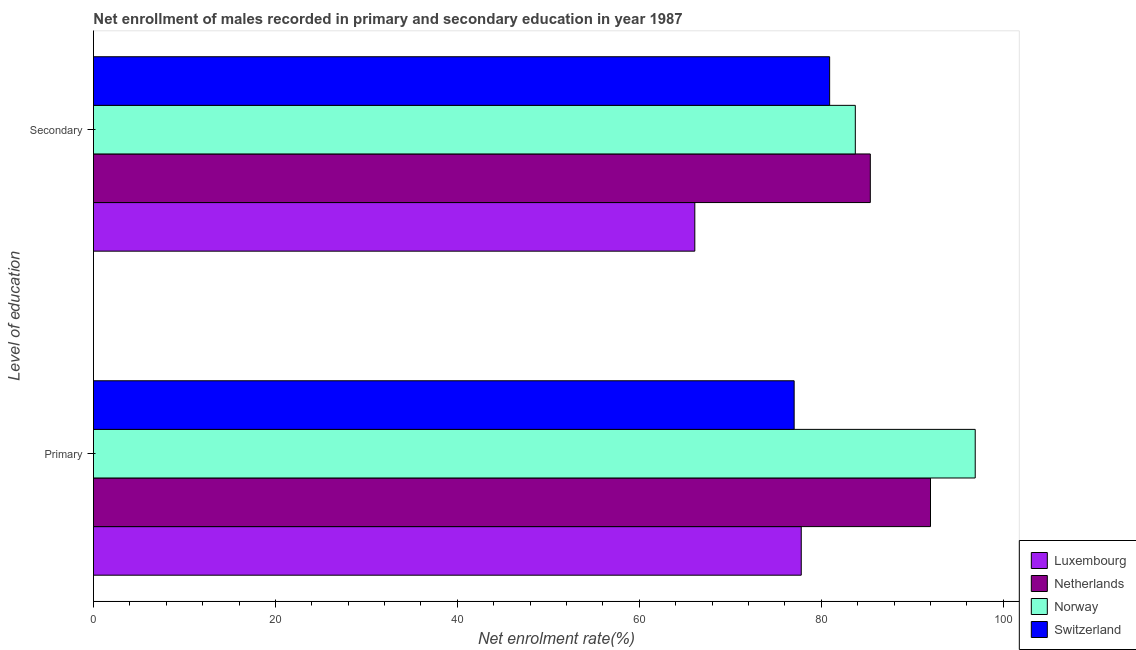How many groups of bars are there?
Your answer should be compact. 2. Are the number of bars per tick equal to the number of legend labels?
Keep it short and to the point. Yes. How many bars are there on the 2nd tick from the top?
Provide a short and direct response. 4. How many bars are there on the 1st tick from the bottom?
Provide a succinct answer. 4. What is the label of the 2nd group of bars from the top?
Give a very brief answer. Primary. What is the enrollment rate in secondary education in Luxembourg?
Make the answer very short. 66.1. Across all countries, what is the maximum enrollment rate in primary education?
Provide a succinct answer. 96.92. Across all countries, what is the minimum enrollment rate in primary education?
Your response must be concise. 77.02. In which country was the enrollment rate in secondary education maximum?
Offer a very short reply. Netherlands. In which country was the enrollment rate in primary education minimum?
Offer a very short reply. Switzerland. What is the total enrollment rate in secondary education in the graph?
Your response must be concise. 316.15. What is the difference between the enrollment rate in primary education in Luxembourg and that in Norway?
Offer a terse response. -19.12. What is the difference between the enrollment rate in secondary education in Luxembourg and the enrollment rate in primary education in Netherlands?
Your answer should be very brief. -25.91. What is the average enrollment rate in secondary education per country?
Your response must be concise. 79.04. What is the difference between the enrollment rate in primary education and enrollment rate in secondary education in Luxembourg?
Make the answer very short. 11.7. In how many countries, is the enrollment rate in secondary education greater than 32 %?
Your answer should be compact. 4. What is the ratio of the enrollment rate in primary education in Netherlands to that in Luxembourg?
Provide a succinct answer. 1.18. What does the 3rd bar from the top in Primary represents?
Provide a short and direct response. Netherlands. What does the 1st bar from the bottom in Secondary represents?
Your response must be concise. Luxembourg. Are all the bars in the graph horizontal?
Make the answer very short. Yes. How many countries are there in the graph?
Provide a short and direct response. 4. Does the graph contain any zero values?
Keep it short and to the point. No. Where does the legend appear in the graph?
Your response must be concise. Bottom right. How many legend labels are there?
Offer a terse response. 4. What is the title of the graph?
Make the answer very short. Net enrollment of males recorded in primary and secondary education in year 1987. Does "High income: OECD" appear as one of the legend labels in the graph?
Give a very brief answer. No. What is the label or title of the X-axis?
Your response must be concise. Net enrolment rate(%). What is the label or title of the Y-axis?
Keep it short and to the point. Level of education. What is the Net enrolment rate(%) of Luxembourg in Primary?
Your answer should be very brief. 77.8. What is the Net enrolment rate(%) in Netherlands in Primary?
Keep it short and to the point. 92. What is the Net enrolment rate(%) in Norway in Primary?
Ensure brevity in your answer.  96.92. What is the Net enrolment rate(%) of Switzerland in Primary?
Offer a very short reply. 77.02. What is the Net enrolment rate(%) of Luxembourg in Secondary?
Ensure brevity in your answer.  66.1. What is the Net enrolment rate(%) in Netherlands in Secondary?
Ensure brevity in your answer.  85.39. What is the Net enrolment rate(%) of Norway in Secondary?
Provide a succinct answer. 83.74. What is the Net enrolment rate(%) in Switzerland in Secondary?
Keep it short and to the point. 80.92. Across all Level of education, what is the maximum Net enrolment rate(%) of Luxembourg?
Give a very brief answer. 77.8. Across all Level of education, what is the maximum Net enrolment rate(%) of Netherlands?
Your response must be concise. 92. Across all Level of education, what is the maximum Net enrolment rate(%) of Norway?
Ensure brevity in your answer.  96.92. Across all Level of education, what is the maximum Net enrolment rate(%) of Switzerland?
Provide a short and direct response. 80.92. Across all Level of education, what is the minimum Net enrolment rate(%) in Luxembourg?
Your response must be concise. 66.1. Across all Level of education, what is the minimum Net enrolment rate(%) of Netherlands?
Provide a succinct answer. 85.39. Across all Level of education, what is the minimum Net enrolment rate(%) of Norway?
Give a very brief answer. 83.74. Across all Level of education, what is the minimum Net enrolment rate(%) in Switzerland?
Provide a short and direct response. 77.02. What is the total Net enrolment rate(%) of Luxembourg in the graph?
Offer a very short reply. 143.9. What is the total Net enrolment rate(%) in Netherlands in the graph?
Your answer should be compact. 177.39. What is the total Net enrolment rate(%) in Norway in the graph?
Offer a terse response. 180.66. What is the total Net enrolment rate(%) in Switzerland in the graph?
Make the answer very short. 157.94. What is the difference between the Net enrolment rate(%) of Luxembourg in Primary and that in Secondary?
Your response must be concise. 11.7. What is the difference between the Net enrolment rate(%) in Netherlands in Primary and that in Secondary?
Make the answer very short. 6.62. What is the difference between the Net enrolment rate(%) in Norway in Primary and that in Secondary?
Keep it short and to the point. 13.18. What is the difference between the Net enrolment rate(%) in Switzerland in Primary and that in Secondary?
Your response must be concise. -3.9. What is the difference between the Net enrolment rate(%) in Luxembourg in Primary and the Net enrolment rate(%) in Netherlands in Secondary?
Offer a terse response. -7.59. What is the difference between the Net enrolment rate(%) of Luxembourg in Primary and the Net enrolment rate(%) of Norway in Secondary?
Your answer should be very brief. -5.94. What is the difference between the Net enrolment rate(%) in Luxembourg in Primary and the Net enrolment rate(%) in Switzerland in Secondary?
Your response must be concise. -3.12. What is the difference between the Net enrolment rate(%) in Netherlands in Primary and the Net enrolment rate(%) in Norway in Secondary?
Provide a short and direct response. 8.26. What is the difference between the Net enrolment rate(%) in Netherlands in Primary and the Net enrolment rate(%) in Switzerland in Secondary?
Ensure brevity in your answer.  11.09. What is the difference between the Net enrolment rate(%) of Norway in Primary and the Net enrolment rate(%) of Switzerland in Secondary?
Provide a succinct answer. 16. What is the average Net enrolment rate(%) in Luxembourg per Level of education?
Offer a very short reply. 71.95. What is the average Net enrolment rate(%) in Netherlands per Level of education?
Give a very brief answer. 88.7. What is the average Net enrolment rate(%) in Norway per Level of education?
Offer a very short reply. 90.33. What is the average Net enrolment rate(%) in Switzerland per Level of education?
Make the answer very short. 78.97. What is the difference between the Net enrolment rate(%) of Luxembourg and Net enrolment rate(%) of Netherlands in Primary?
Keep it short and to the point. -14.21. What is the difference between the Net enrolment rate(%) of Luxembourg and Net enrolment rate(%) of Norway in Primary?
Give a very brief answer. -19.12. What is the difference between the Net enrolment rate(%) in Luxembourg and Net enrolment rate(%) in Switzerland in Primary?
Provide a succinct answer. 0.78. What is the difference between the Net enrolment rate(%) of Netherlands and Net enrolment rate(%) of Norway in Primary?
Your response must be concise. -4.92. What is the difference between the Net enrolment rate(%) of Netherlands and Net enrolment rate(%) of Switzerland in Primary?
Keep it short and to the point. 14.99. What is the difference between the Net enrolment rate(%) of Norway and Net enrolment rate(%) of Switzerland in Primary?
Your answer should be very brief. 19.9. What is the difference between the Net enrolment rate(%) of Luxembourg and Net enrolment rate(%) of Netherlands in Secondary?
Offer a terse response. -19.29. What is the difference between the Net enrolment rate(%) in Luxembourg and Net enrolment rate(%) in Norway in Secondary?
Ensure brevity in your answer.  -17.64. What is the difference between the Net enrolment rate(%) in Luxembourg and Net enrolment rate(%) in Switzerland in Secondary?
Offer a terse response. -14.82. What is the difference between the Net enrolment rate(%) of Netherlands and Net enrolment rate(%) of Norway in Secondary?
Your response must be concise. 1.65. What is the difference between the Net enrolment rate(%) in Netherlands and Net enrolment rate(%) in Switzerland in Secondary?
Offer a very short reply. 4.47. What is the difference between the Net enrolment rate(%) of Norway and Net enrolment rate(%) of Switzerland in Secondary?
Your response must be concise. 2.82. What is the ratio of the Net enrolment rate(%) in Luxembourg in Primary to that in Secondary?
Provide a short and direct response. 1.18. What is the ratio of the Net enrolment rate(%) in Netherlands in Primary to that in Secondary?
Offer a terse response. 1.08. What is the ratio of the Net enrolment rate(%) in Norway in Primary to that in Secondary?
Your response must be concise. 1.16. What is the ratio of the Net enrolment rate(%) in Switzerland in Primary to that in Secondary?
Offer a terse response. 0.95. What is the difference between the highest and the second highest Net enrolment rate(%) in Luxembourg?
Provide a succinct answer. 11.7. What is the difference between the highest and the second highest Net enrolment rate(%) in Netherlands?
Offer a very short reply. 6.62. What is the difference between the highest and the second highest Net enrolment rate(%) in Norway?
Give a very brief answer. 13.18. What is the difference between the highest and the second highest Net enrolment rate(%) in Switzerland?
Offer a very short reply. 3.9. What is the difference between the highest and the lowest Net enrolment rate(%) of Luxembourg?
Offer a very short reply. 11.7. What is the difference between the highest and the lowest Net enrolment rate(%) of Netherlands?
Your answer should be compact. 6.62. What is the difference between the highest and the lowest Net enrolment rate(%) of Norway?
Give a very brief answer. 13.18. What is the difference between the highest and the lowest Net enrolment rate(%) in Switzerland?
Keep it short and to the point. 3.9. 